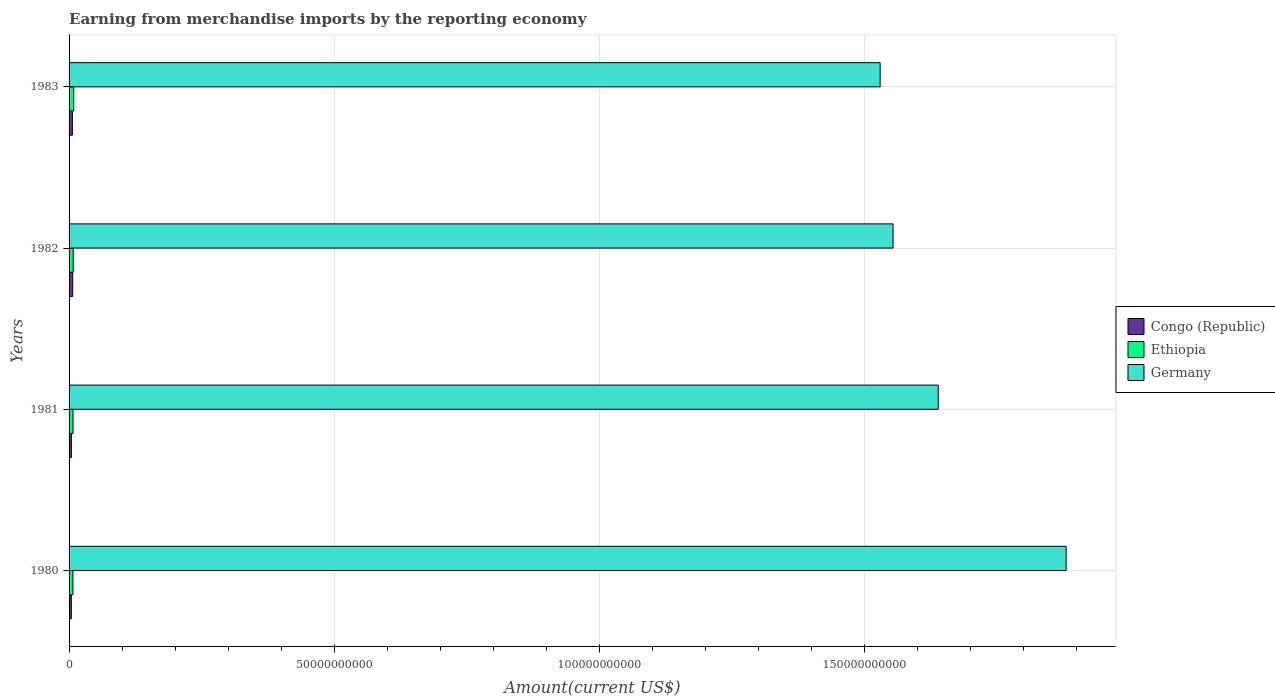Are the number of bars per tick equal to the number of legend labels?
Offer a very short reply. Yes. Are the number of bars on each tick of the Y-axis equal?
Ensure brevity in your answer.  Yes. How many bars are there on the 3rd tick from the bottom?
Offer a terse response. 3. What is the label of the 2nd group of bars from the top?
Keep it short and to the point. 1982. In how many cases, is the number of bars for a given year not equal to the number of legend labels?
Give a very brief answer. 0. What is the amount earned from merchandise imports in Ethiopia in 1983?
Offer a very short reply. 8.79e+08. Across all years, what is the maximum amount earned from merchandise imports in Congo (Republic)?
Give a very brief answer. 6.84e+08. Across all years, what is the minimum amount earned from merchandise imports in Congo (Republic)?
Provide a short and direct response. 4.27e+08. In which year was the amount earned from merchandise imports in Germany maximum?
Keep it short and to the point. 1980. In which year was the amount earned from merchandise imports in Germany minimum?
Keep it short and to the point. 1983. What is the total amount earned from merchandise imports in Ethiopia in the graph?
Ensure brevity in your answer.  3.12e+09. What is the difference between the amount earned from merchandise imports in Congo (Republic) in 1980 and that in 1981?
Your response must be concise. -8.87e+06. What is the difference between the amount earned from merchandise imports in Congo (Republic) in 1983 and the amount earned from merchandise imports in Ethiopia in 1982?
Make the answer very short. -1.59e+08. What is the average amount earned from merchandise imports in Congo (Republic) per year?
Keep it short and to the point. 5.44e+08. In the year 1980, what is the difference between the amount earned from merchandise imports in Congo (Republic) and amount earned from merchandise imports in Germany?
Offer a terse response. -1.88e+11. What is the ratio of the amount earned from merchandise imports in Germany in 1981 to that in 1982?
Give a very brief answer. 1.05. Is the amount earned from merchandise imports in Congo (Republic) in 1982 less than that in 1983?
Ensure brevity in your answer.  No. Is the difference between the amount earned from merchandise imports in Congo (Republic) in 1980 and 1982 greater than the difference between the amount earned from merchandise imports in Germany in 1980 and 1982?
Your response must be concise. No. What is the difference between the highest and the second highest amount earned from merchandise imports in Ethiopia?
Your answer should be compact. 9.28e+07. What is the difference between the highest and the lowest amount earned from merchandise imports in Ethiopia?
Keep it short and to the point. 1.57e+08. Is the sum of the amount earned from merchandise imports in Congo (Republic) in 1981 and 1982 greater than the maximum amount earned from merchandise imports in Germany across all years?
Your response must be concise. No. What does the 2nd bar from the bottom in 1982 represents?
Make the answer very short. Ethiopia. Are all the bars in the graph horizontal?
Keep it short and to the point. Yes. How many years are there in the graph?
Keep it short and to the point. 4. What is the difference between two consecutive major ticks on the X-axis?
Provide a succinct answer. 5.00e+1. Does the graph contain any zero values?
Keep it short and to the point. No. How many legend labels are there?
Offer a terse response. 3. How are the legend labels stacked?
Keep it short and to the point. Vertical. What is the title of the graph?
Ensure brevity in your answer.  Earning from merchandise imports by the reporting economy. What is the label or title of the X-axis?
Your response must be concise. Amount(current US$). What is the label or title of the Y-axis?
Offer a very short reply. Years. What is the Amount(current US$) of Congo (Republic) in 1980?
Give a very brief answer. 4.27e+08. What is the Amount(current US$) of Ethiopia in 1980?
Your response must be concise. 7.22e+08. What is the Amount(current US$) in Germany in 1980?
Your answer should be compact. 1.88e+11. What is the Amount(current US$) in Congo (Republic) in 1981?
Your answer should be compact. 4.36e+08. What is the Amount(current US$) of Ethiopia in 1981?
Make the answer very short. 7.38e+08. What is the Amount(current US$) in Germany in 1981?
Your answer should be compact. 1.64e+11. What is the Amount(current US$) of Congo (Republic) in 1982?
Ensure brevity in your answer.  6.84e+08. What is the Amount(current US$) in Ethiopia in 1982?
Offer a very short reply. 7.86e+08. What is the Amount(current US$) in Germany in 1982?
Provide a succinct answer. 1.55e+11. What is the Amount(current US$) in Congo (Republic) in 1983?
Your answer should be compact. 6.27e+08. What is the Amount(current US$) of Ethiopia in 1983?
Offer a terse response. 8.79e+08. What is the Amount(current US$) of Germany in 1983?
Provide a succinct answer. 1.53e+11. Across all years, what is the maximum Amount(current US$) of Congo (Republic)?
Make the answer very short. 6.84e+08. Across all years, what is the maximum Amount(current US$) in Ethiopia?
Provide a short and direct response. 8.79e+08. Across all years, what is the maximum Amount(current US$) in Germany?
Your answer should be very brief. 1.88e+11. Across all years, what is the minimum Amount(current US$) in Congo (Republic)?
Keep it short and to the point. 4.27e+08. Across all years, what is the minimum Amount(current US$) in Ethiopia?
Provide a short and direct response. 7.22e+08. Across all years, what is the minimum Amount(current US$) in Germany?
Offer a terse response. 1.53e+11. What is the total Amount(current US$) in Congo (Republic) in the graph?
Give a very brief answer. 2.17e+09. What is the total Amount(current US$) in Ethiopia in the graph?
Give a very brief answer. 3.12e+09. What is the total Amount(current US$) in Germany in the graph?
Offer a terse response. 6.60e+11. What is the difference between the Amount(current US$) in Congo (Republic) in 1980 and that in 1981?
Ensure brevity in your answer.  -8.87e+06. What is the difference between the Amount(current US$) of Ethiopia in 1980 and that in 1981?
Your answer should be compact. -1.56e+07. What is the difference between the Amount(current US$) of Germany in 1980 and that in 1981?
Provide a succinct answer. 2.41e+1. What is the difference between the Amount(current US$) of Congo (Republic) in 1980 and that in 1982?
Keep it short and to the point. -2.57e+08. What is the difference between the Amount(current US$) of Ethiopia in 1980 and that in 1982?
Provide a succinct answer. -6.41e+07. What is the difference between the Amount(current US$) of Germany in 1980 and that in 1982?
Your answer should be very brief. 3.26e+1. What is the difference between the Amount(current US$) of Congo (Republic) in 1980 and that in 1983?
Make the answer very short. -2.00e+08. What is the difference between the Amount(current US$) of Ethiopia in 1980 and that in 1983?
Provide a succinct answer. -1.57e+08. What is the difference between the Amount(current US$) of Germany in 1980 and that in 1983?
Give a very brief answer. 3.51e+1. What is the difference between the Amount(current US$) in Congo (Republic) in 1981 and that in 1982?
Ensure brevity in your answer.  -2.49e+08. What is the difference between the Amount(current US$) in Ethiopia in 1981 and that in 1982?
Make the answer very short. -4.85e+07. What is the difference between the Amount(current US$) of Germany in 1981 and that in 1982?
Provide a succinct answer. 8.52e+09. What is the difference between the Amount(current US$) of Congo (Republic) in 1981 and that in 1983?
Make the answer very short. -1.91e+08. What is the difference between the Amount(current US$) in Ethiopia in 1981 and that in 1983?
Make the answer very short. -1.41e+08. What is the difference between the Amount(current US$) in Germany in 1981 and that in 1983?
Your response must be concise. 1.10e+1. What is the difference between the Amount(current US$) of Congo (Republic) in 1982 and that in 1983?
Provide a succinct answer. 5.74e+07. What is the difference between the Amount(current US$) of Ethiopia in 1982 and that in 1983?
Your answer should be very brief. -9.28e+07. What is the difference between the Amount(current US$) of Germany in 1982 and that in 1983?
Your response must be concise. 2.44e+09. What is the difference between the Amount(current US$) in Congo (Republic) in 1980 and the Amount(current US$) in Ethiopia in 1981?
Offer a very short reply. -3.11e+08. What is the difference between the Amount(current US$) in Congo (Republic) in 1980 and the Amount(current US$) in Germany in 1981?
Provide a short and direct response. -1.63e+11. What is the difference between the Amount(current US$) in Ethiopia in 1980 and the Amount(current US$) in Germany in 1981?
Keep it short and to the point. -1.63e+11. What is the difference between the Amount(current US$) in Congo (Republic) in 1980 and the Amount(current US$) in Ethiopia in 1982?
Your answer should be compact. -3.59e+08. What is the difference between the Amount(current US$) in Congo (Republic) in 1980 and the Amount(current US$) in Germany in 1982?
Provide a short and direct response. -1.55e+11. What is the difference between the Amount(current US$) in Ethiopia in 1980 and the Amount(current US$) in Germany in 1982?
Make the answer very short. -1.55e+11. What is the difference between the Amount(current US$) in Congo (Republic) in 1980 and the Amount(current US$) in Ethiopia in 1983?
Offer a very short reply. -4.52e+08. What is the difference between the Amount(current US$) of Congo (Republic) in 1980 and the Amount(current US$) of Germany in 1983?
Offer a very short reply. -1.53e+11. What is the difference between the Amount(current US$) in Ethiopia in 1980 and the Amount(current US$) in Germany in 1983?
Offer a terse response. -1.52e+11. What is the difference between the Amount(current US$) in Congo (Republic) in 1981 and the Amount(current US$) in Ethiopia in 1982?
Ensure brevity in your answer.  -3.50e+08. What is the difference between the Amount(current US$) of Congo (Republic) in 1981 and the Amount(current US$) of Germany in 1982?
Offer a terse response. -1.55e+11. What is the difference between the Amount(current US$) of Ethiopia in 1981 and the Amount(current US$) of Germany in 1982?
Provide a short and direct response. -1.55e+11. What is the difference between the Amount(current US$) in Congo (Republic) in 1981 and the Amount(current US$) in Ethiopia in 1983?
Provide a succinct answer. -4.43e+08. What is the difference between the Amount(current US$) in Congo (Republic) in 1981 and the Amount(current US$) in Germany in 1983?
Make the answer very short. -1.53e+11. What is the difference between the Amount(current US$) of Ethiopia in 1981 and the Amount(current US$) of Germany in 1983?
Give a very brief answer. -1.52e+11. What is the difference between the Amount(current US$) of Congo (Republic) in 1982 and the Amount(current US$) of Ethiopia in 1983?
Ensure brevity in your answer.  -1.95e+08. What is the difference between the Amount(current US$) of Congo (Republic) in 1982 and the Amount(current US$) of Germany in 1983?
Your answer should be compact. -1.52e+11. What is the difference between the Amount(current US$) of Ethiopia in 1982 and the Amount(current US$) of Germany in 1983?
Provide a short and direct response. -1.52e+11. What is the average Amount(current US$) of Congo (Republic) per year?
Your answer should be compact. 5.44e+08. What is the average Amount(current US$) of Ethiopia per year?
Give a very brief answer. 7.81e+08. What is the average Amount(current US$) in Germany per year?
Your answer should be very brief. 1.65e+11. In the year 1980, what is the difference between the Amount(current US$) of Congo (Republic) and Amount(current US$) of Ethiopia?
Give a very brief answer. -2.95e+08. In the year 1980, what is the difference between the Amount(current US$) of Congo (Republic) and Amount(current US$) of Germany?
Provide a short and direct response. -1.88e+11. In the year 1980, what is the difference between the Amount(current US$) in Ethiopia and Amount(current US$) in Germany?
Give a very brief answer. -1.87e+11. In the year 1981, what is the difference between the Amount(current US$) in Congo (Republic) and Amount(current US$) in Ethiopia?
Your answer should be compact. -3.02e+08. In the year 1981, what is the difference between the Amount(current US$) in Congo (Republic) and Amount(current US$) in Germany?
Give a very brief answer. -1.63e+11. In the year 1981, what is the difference between the Amount(current US$) in Ethiopia and Amount(current US$) in Germany?
Ensure brevity in your answer.  -1.63e+11. In the year 1982, what is the difference between the Amount(current US$) of Congo (Republic) and Amount(current US$) of Ethiopia?
Offer a very short reply. -1.02e+08. In the year 1982, what is the difference between the Amount(current US$) of Congo (Republic) and Amount(current US$) of Germany?
Your answer should be compact. -1.55e+11. In the year 1982, what is the difference between the Amount(current US$) in Ethiopia and Amount(current US$) in Germany?
Provide a succinct answer. -1.55e+11. In the year 1983, what is the difference between the Amount(current US$) of Congo (Republic) and Amount(current US$) of Ethiopia?
Offer a very short reply. -2.52e+08. In the year 1983, what is the difference between the Amount(current US$) of Congo (Republic) and Amount(current US$) of Germany?
Your response must be concise. -1.52e+11. In the year 1983, what is the difference between the Amount(current US$) in Ethiopia and Amount(current US$) in Germany?
Give a very brief answer. -1.52e+11. What is the ratio of the Amount(current US$) of Congo (Republic) in 1980 to that in 1981?
Your response must be concise. 0.98. What is the ratio of the Amount(current US$) of Ethiopia in 1980 to that in 1981?
Provide a succinct answer. 0.98. What is the ratio of the Amount(current US$) of Germany in 1980 to that in 1981?
Your answer should be very brief. 1.15. What is the ratio of the Amount(current US$) of Congo (Republic) in 1980 to that in 1982?
Your answer should be very brief. 0.62. What is the ratio of the Amount(current US$) in Ethiopia in 1980 to that in 1982?
Your answer should be very brief. 0.92. What is the ratio of the Amount(current US$) of Germany in 1980 to that in 1982?
Ensure brevity in your answer.  1.21. What is the ratio of the Amount(current US$) of Congo (Republic) in 1980 to that in 1983?
Provide a succinct answer. 0.68. What is the ratio of the Amount(current US$) of Ethiopia in 1980 to that in 1983?
Give a very brief answer. 0.82. What is the ratio of the Amount(current US$) in Germany in 1980 to that in 1983?
Provide a succinct answer. 1.23. What is the ratio of the Amount(current US$) of Congo (Republic) in 1981 to that in 1982?
Ensure brevity in your answer.  0.64. What is the ratio of the Amount(current US$) in Ethiopia in 1981 to that in 1982?
Make the answer very short. 0.94. What is the ratio of the Amount(current US$) in Germany in 1981 to that in 1982?
Offer a very short reply. 1.05. What is the ratio of the Amount(current US$) in Congo (Republic) in 1981 to that in 1983?
Ensure brevity in your answer.  0.7. What is the ratio of the Amount(current US$) in Ethiopia in 1981 to that in 1983?
Your answer should be very brief. 0.84. What is the ratio of the Amount(current US$) in Germany in 1981 to that in 1983?
Keep it short and to the point. 1.07. What is the ratio of the Amount(current US$) of Congo (Republic) in 1982 to that in 1983?
Offer a very short reply. 1.09. What is the ratio of the Amount(current US$) of Ethiopia in 1982 to that in 1983?
Your answer should be compact. 0.89. What is the ratio of the Amount(current US$) in Germany in 1982 to that in 1983?
Make the answer very short. 1.02. What is the difference between the highest and the second highest Amount(current US$) in Congo (Republic)?
Your answer should be compact. 5.74e+07. What is the difference between the highest and the second highest Amount(current US$) of Ethiopia?
Your answer should be compact. 9.28e+07. What is the difference between the highest and the second highest Amount(current US$) of Germany?
Your response must be concise. 2.41e+1. What is the difference between the highest and the lowest Amount(current US$) in Congo (Republic)?
Your answer should be very brief. 2.57e+08. What is the difference between the highest and the lowest Amount(current US$) in Ethiopia?
Ensure brevity in your answer.  1.57e+08. What is the difference between the highest and the lowest Amount(current US$) in Germany?
Provide a succinct answer. 3.51e+1. 